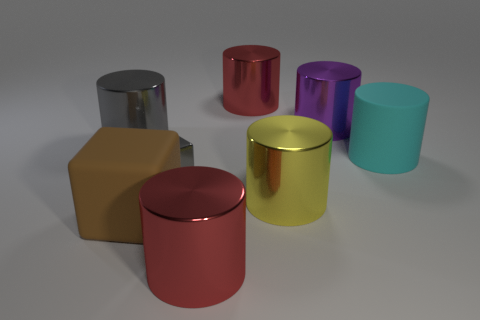Subtract all large purple shiny cylinders. How many cylinders are left? 5 Add 1 large cyan matte cylinders. How many objects exist? 9 Subtract 3 cylinders. How many cylinders are left? 3 Subtract all cylinders. How many objects are left? 2 Subtract 1 brown cubes. How many objects are left? 7 Subtract all red cylinders. Subtract all cyan blocks. How many cylinders are left? 4 Subtract all red blocks. How many green cylinders are left? 0 Subtract all big matte cylinders. Subtract all gray objects. How many objects are left? 5 Add 4 small shiny cubes. How many small shiny cubes are left? 5 Add 3 small purple matte cylinders. How many small purple matte cylinders exist? 3 